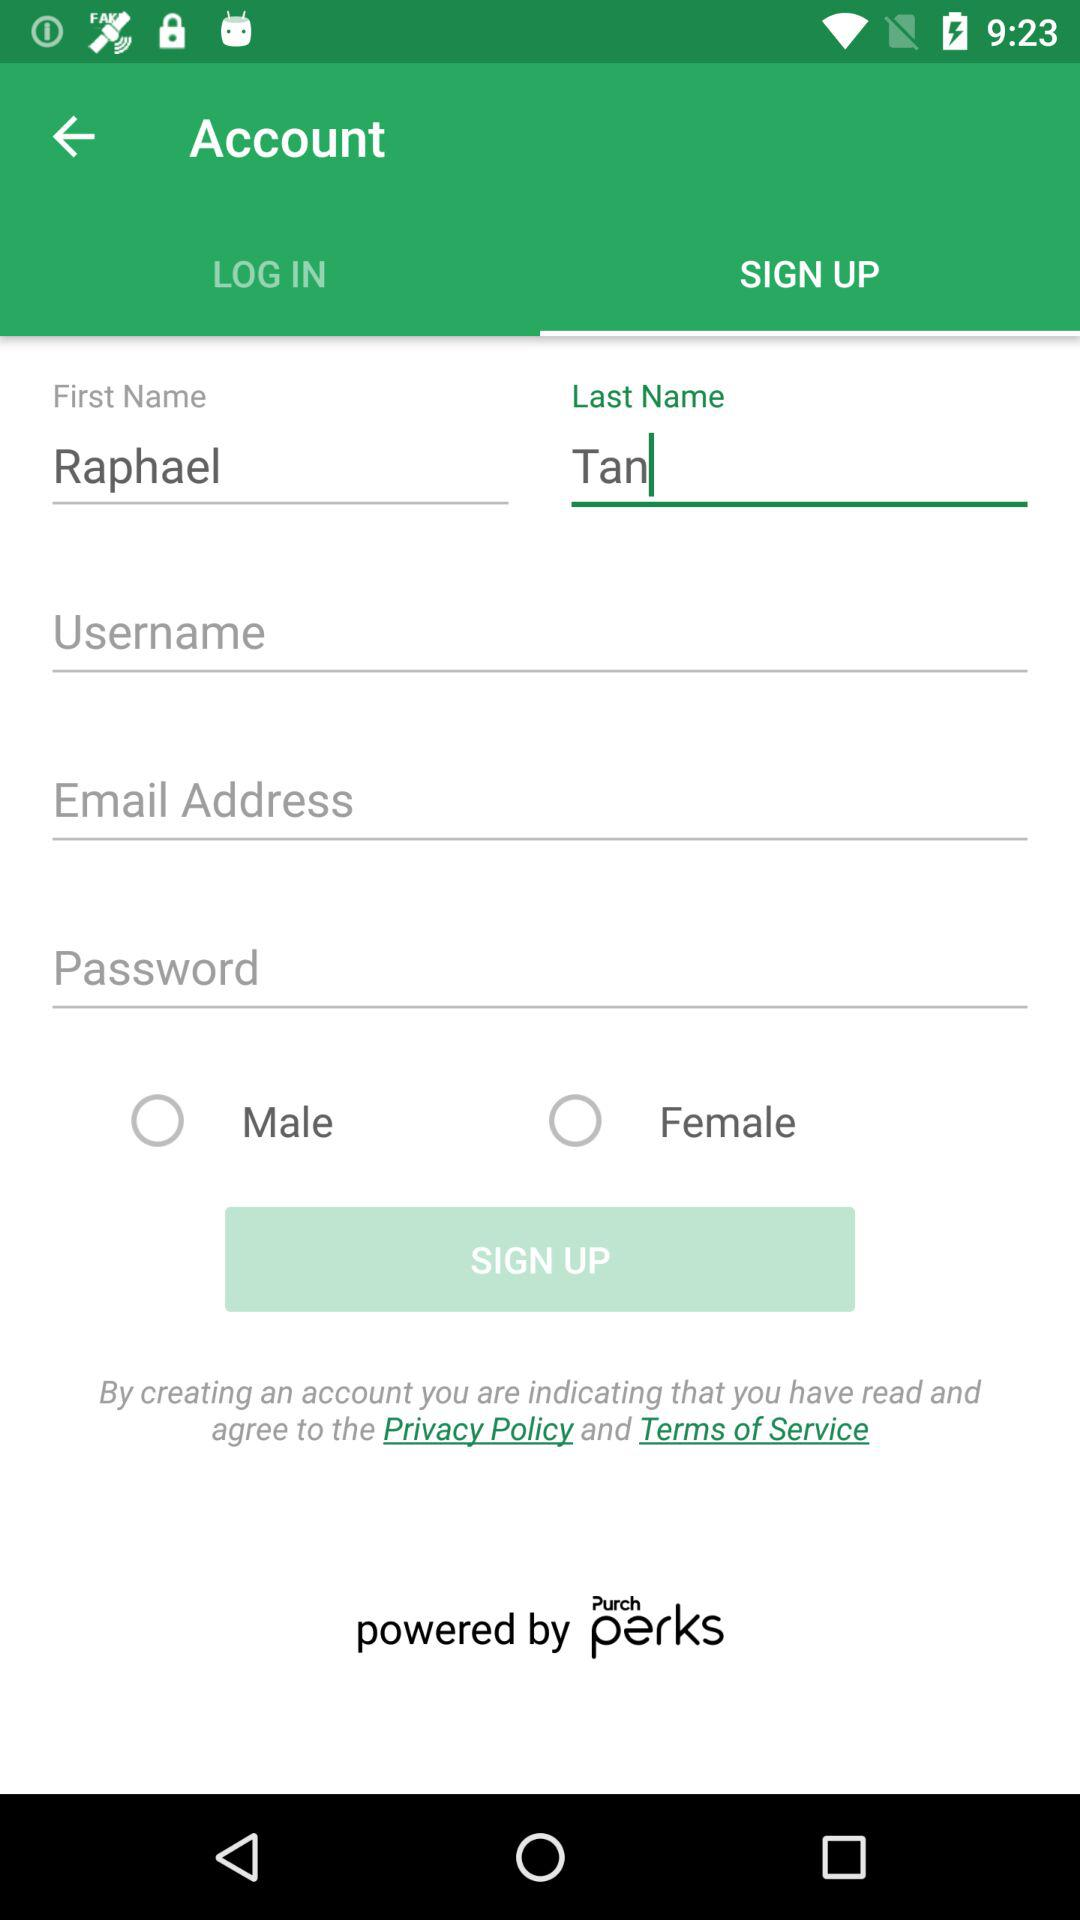By what company is the application powered? The application is powered by Purch. 